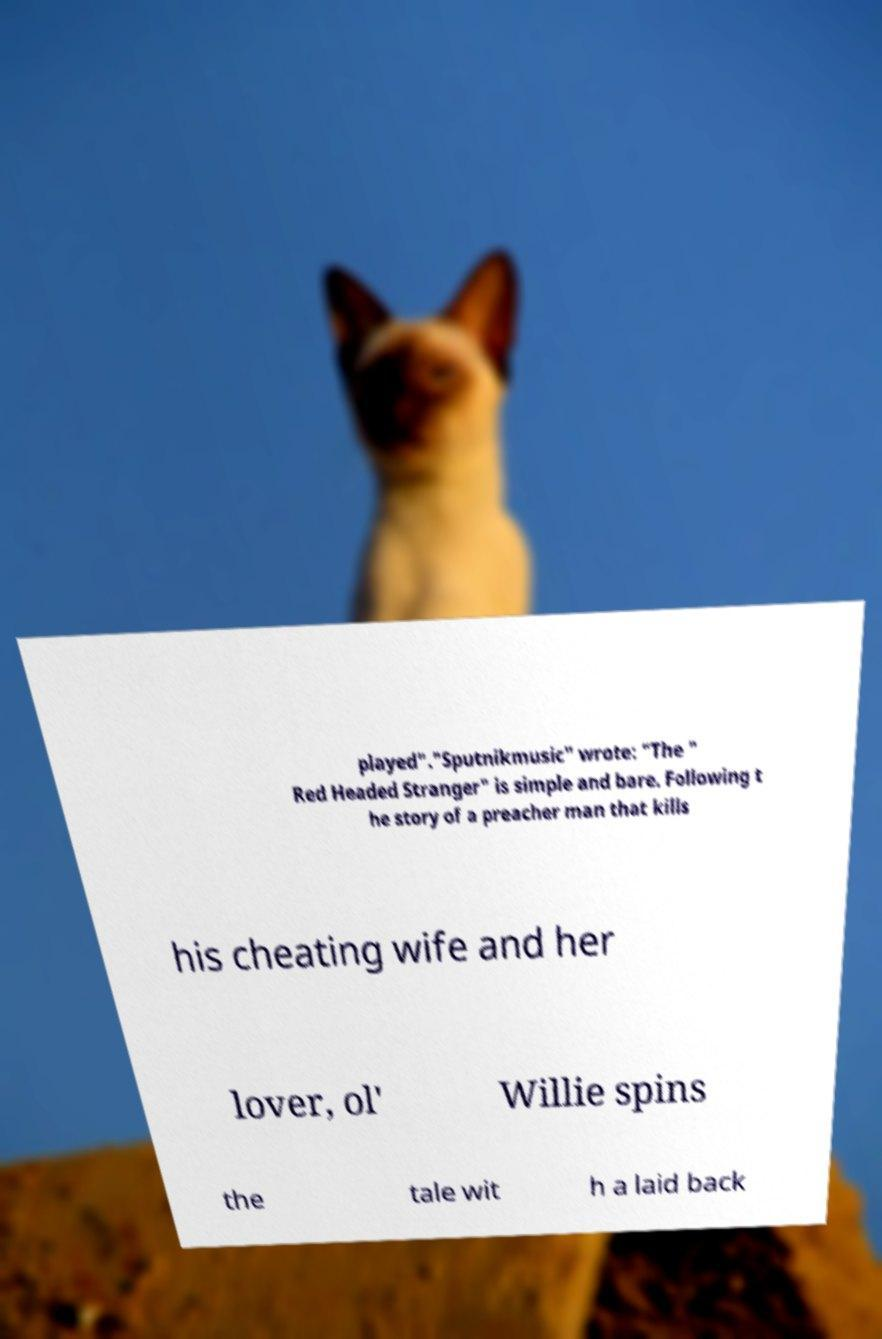I need the written content from this picture converted into text. Can you do that? played"."Sputnikmusic" wrote: "The " Red Headed Stranger" is simple and bare. Following t he story of a preacher man that kills his cheating wife and her lover, ol' Willie spins the tale wit h a laid back 